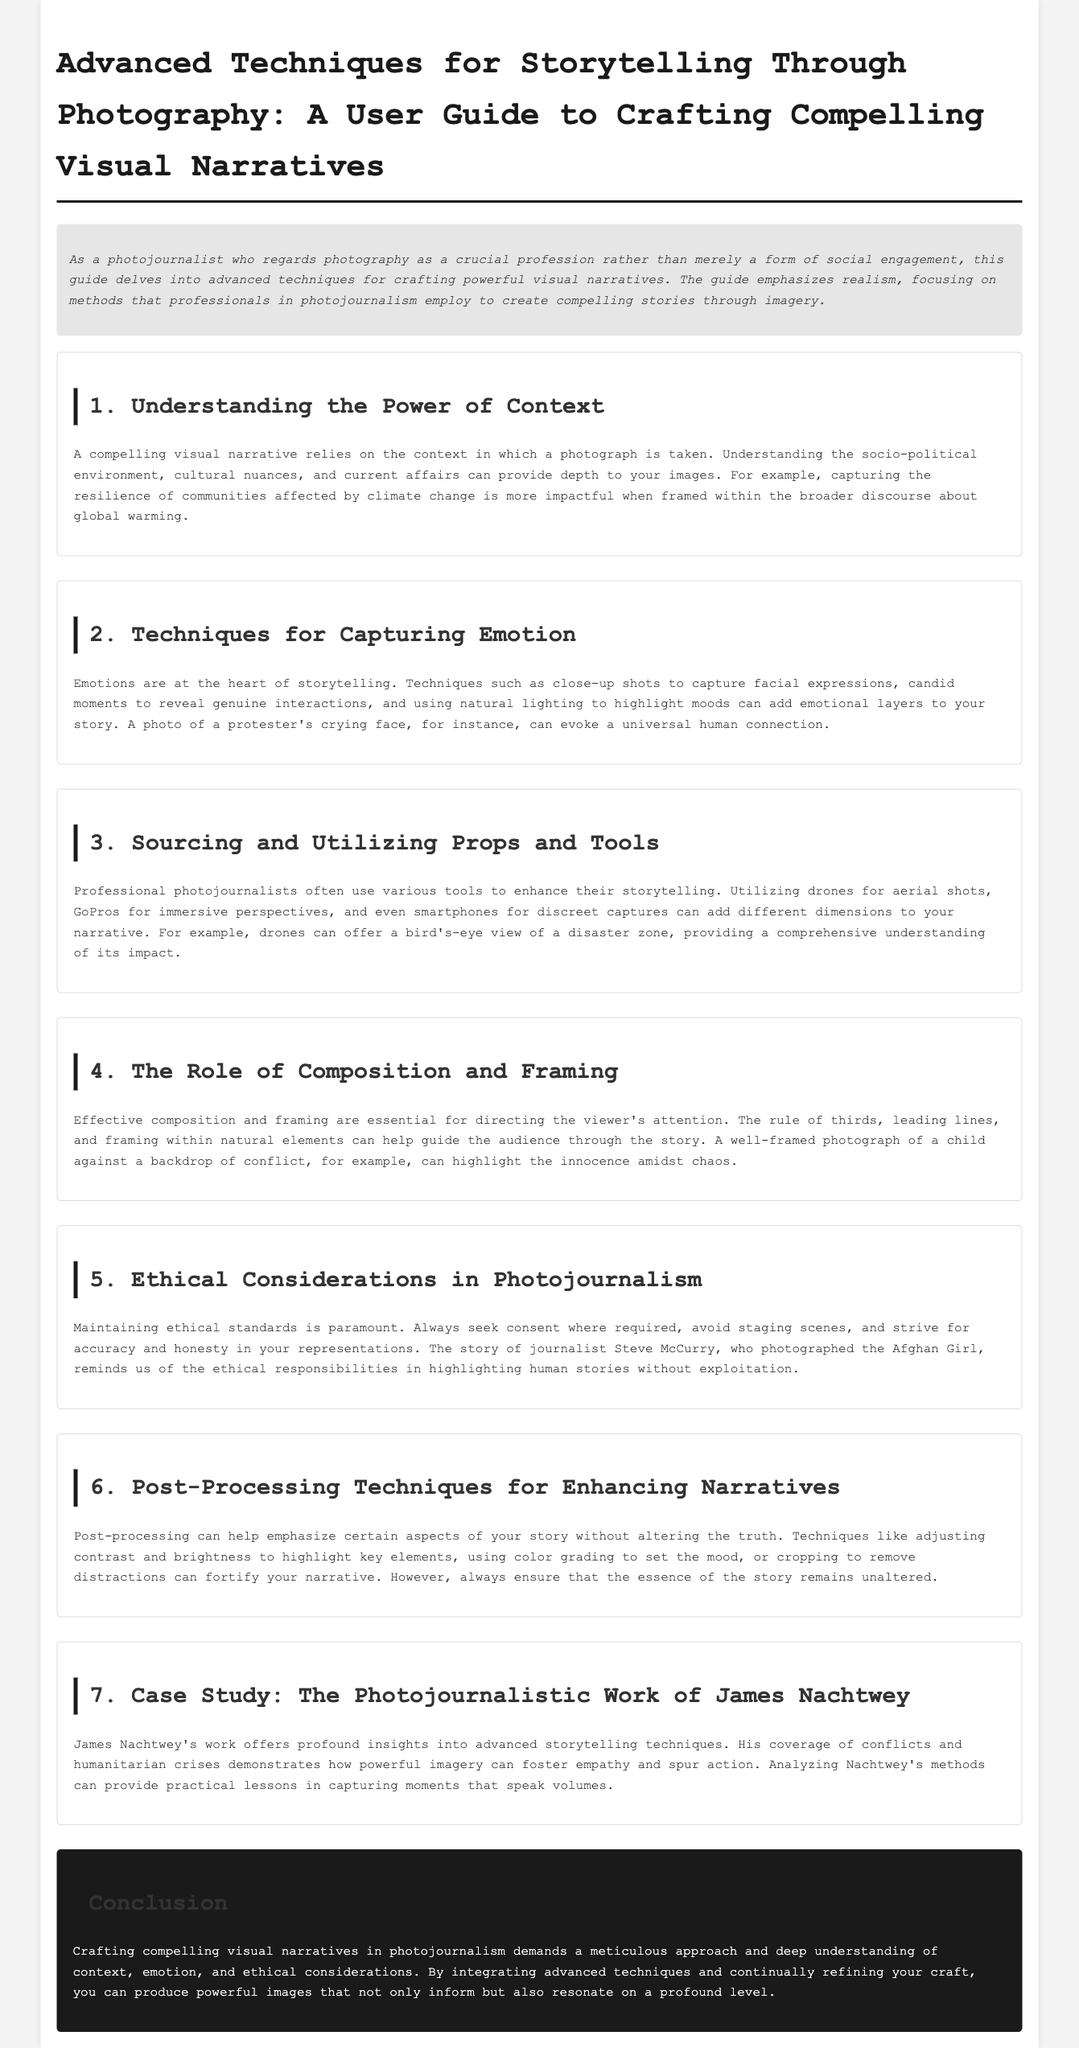What is the main focus of this guide? The guide emphasizes realism, focusing on methods that professionals in photojournalism employ to create compelling stories through imagery.
Answer: realism What are the techniques to capture emotion? Techniques such as close-up shots to capture facial expressions, candid moments to reveal genuine interactions, and using natural lighting to highlight moods can add emotional layers to your story.
Answer: close-up shots, candid moments, natural lighting What should be maintained according to ethical considerations in photojournalism? Maintaining ethical standards is paramount.
Answer: ethical standards Who is mentioned as a case study in the document? James Nachtwey's work offers profound insights into advanced storytelling techniques.
Answer: James Nachtwey What aspect does post-processing emphasize in storytelling? Post-processing can help emphasize certain aspects of your story without altering the truth.
Answer: without altering the truth How can composition and framing guide the audience? Effective composition and framing are essential for directing the viewer's attention.
Answer: directing the viewer's attention 